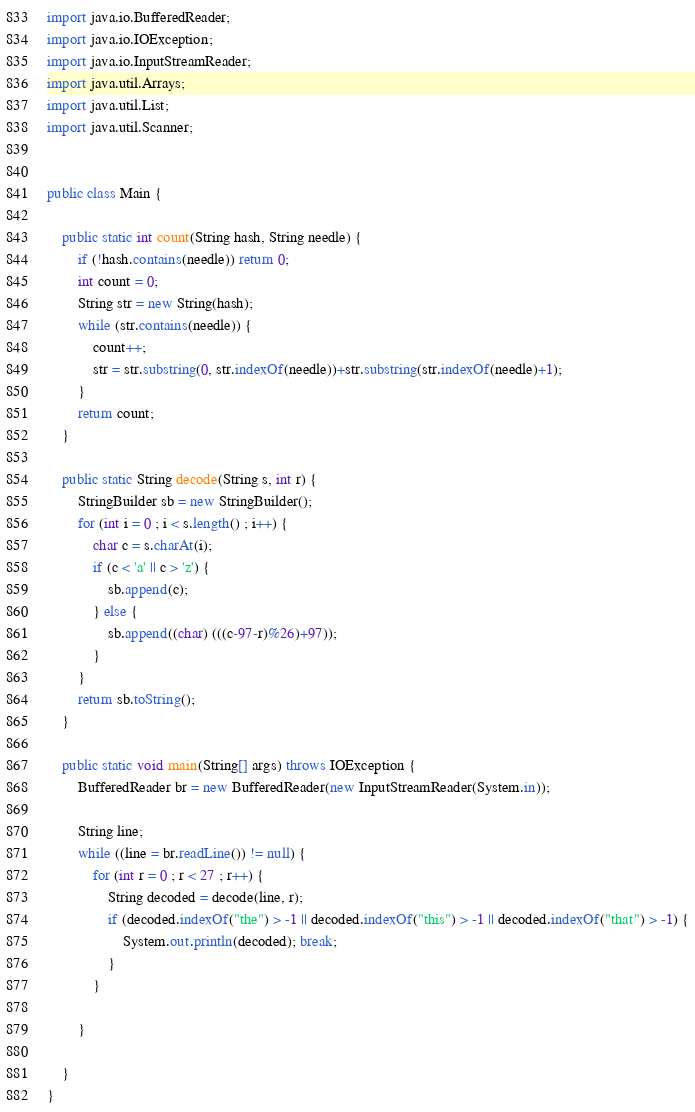Convert code to text. <code><loc_0><loc_0><loc_500><loc_500><_Java_>import java.io.BufferedReader;
import java.io.IOException;
import java.io.InputStreamReader;
import java.util.Arrays;
import java.util.List;
import java.util.Scanner;


public class Main {

	public static int count(String hash, String needle) {
		if (!hash.contains(needle)) return 0;
		int count = 0;
		String str = new String(hash);
		while (str.contains(needle)) {
			count++;
			str = str.substring(0, str.indexOf(needle))+str.substring(str.indexOf(needle)+1);
		}
		return count;
	}

	public static String decode(String s, int r) {
		StringBuilder sb = new StringBuilder();
		for (int i = 0 ; i < s.length() ; i++) {
			char c = s.charAt(i);
			if (c < 'a' || c > 'z') {
				sb.append(c);
			} else {
				sb.append((char) (((c-97-r)%26)+97));
			}
		}
		return sb.toString();
	}

	public static void main(String[] args) throws IOException {
		BufferedReader br = new BufferedReader(new InputStreamReader(System.in));

		String line;
		while ((line = br.readLine()) != null) {
			for (int r = 0 ; r < 27 ; r++) {
				String decoded = decode(line, r);
				if (decoded.indexOf("the") > -1 || decoded.indexOf("this") > -1 || decoded.indexOf("that") > -1) {
					System.out.println(decoded); break;
				}
			}

		}

	}
}</code> 